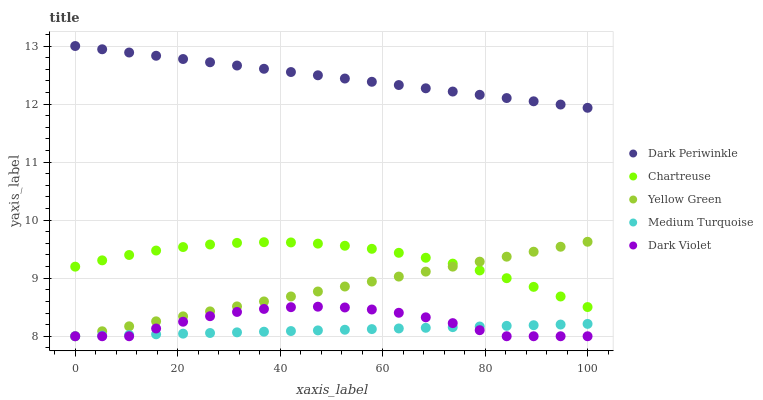Does Medium Turquoise have the minimum area under the curve?
Answer yes or no. Yes. Does Dark Periwinkle have the maximum area under the curve?
Answer yes or no. Yes. Does Dark Violet have the minimum area under the curve?
Answer yes or no. No. Does Dark Violet have the maximum area under the curve?
Answer yes or no. No. Is Dark Periwinkle the smoothest?
Answer yes or no. Yes. Is Dark Violet the roughest?
Answer yes or no. Yes. Is Dark Violet the smoothest?
Answer yes or no. No. Is Dark Periwinkle the roughest?
Answer yes or no. No. Does Dark Violet have the lowest value?
Answer yes or no. Yes. Does Dark Periwinkle have the lowest value?
Answer yes or no. No. Does Dark Periwinkle have the highest value?
Answer yes or no. Yes. Does Dark Violet have the highest value?
Answer yes or no. No. Is Medium Turquoise less than Dark Periwinkle?
Answer yes or no. Yes. Is Dark Periwinkle greater than Medium Turquoise?
Answer yes or no. Yes. Does Medium Turquoise intersect Yellow Green?
Answer yes or no. Yes. Is Medium Turquoise less than Yellow Green?
Answer yes or no. No. Is Medium Turquoise greater than Yellow Green?
Answer yes or no. No. Does Medium Turquoise intersect Dark Periwinkle?
Answer yes or no. No. 